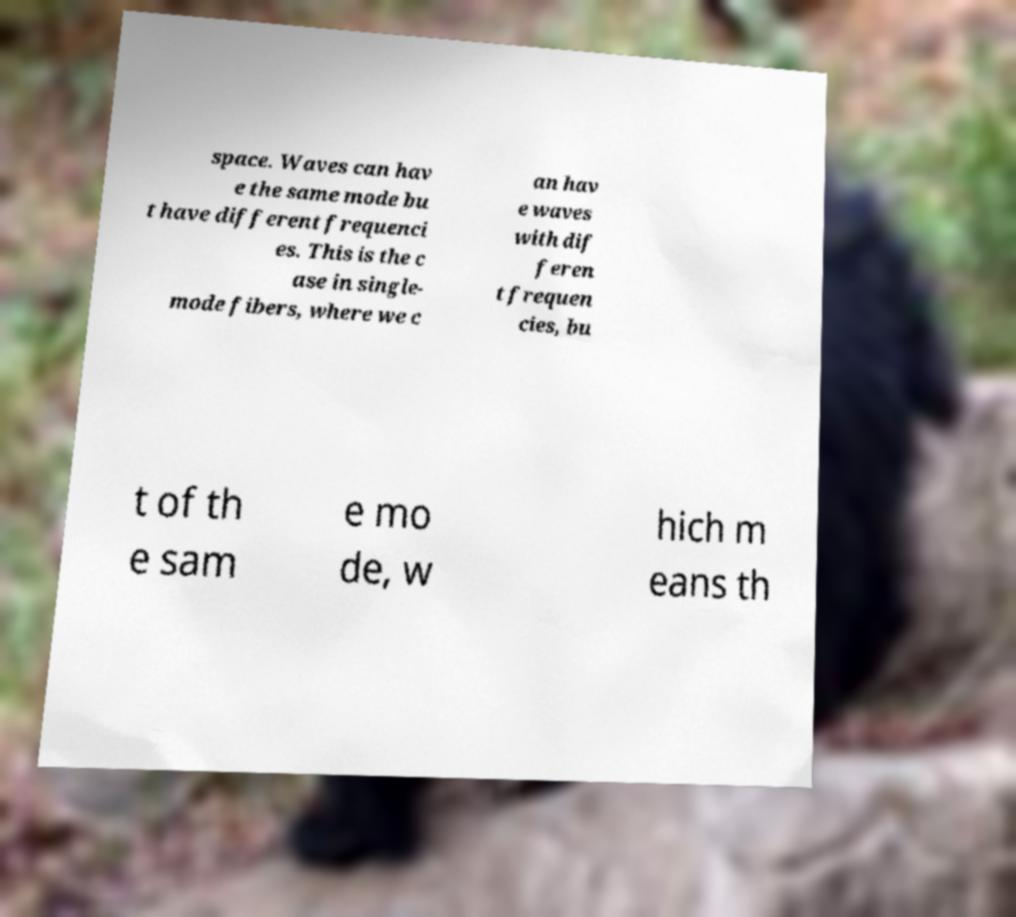For documentation purposes, I need the text within this image transcribed. Could you provide that? space. Waves can hav e the same mode bu t have different frequenci es. This is the c ase in single- mode fibers, where we c an hav e waves with dif feren t frequen cies, bu t of th e sam e mo de, w hich m eans th 